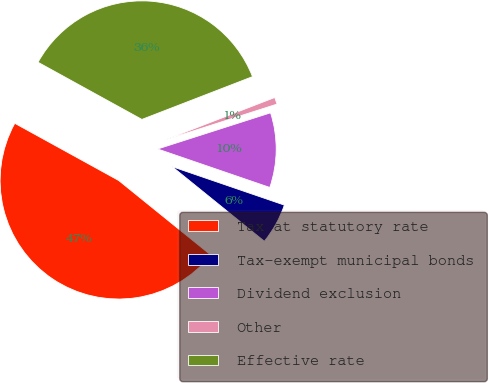Convert chart. <chart><loc_0><loc_0><loc_500><loc_500><pie_chart><fcel>Tax at statutory rate<fcel>Tax-exempt municipal bonds<fcel>Dividend exclusion<fcel>Other<fcel>Effective rate<nl><fcel>47.18%<fcel>5.57%<fcel>10.19%<fcel>0.94%<fcel>36.12%<nl></chart> 